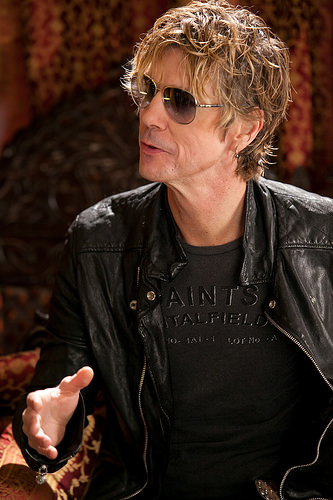<image>
Can you confirm if the sunglasses is on the head? Yes. Looking at the image, I can see the sunglasses is positioned on top of the head, with the head providing support. 